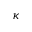Convert formula to latex. <formula><loc_0><loc_0><loc_500><loc_500>\kappa</formula> 